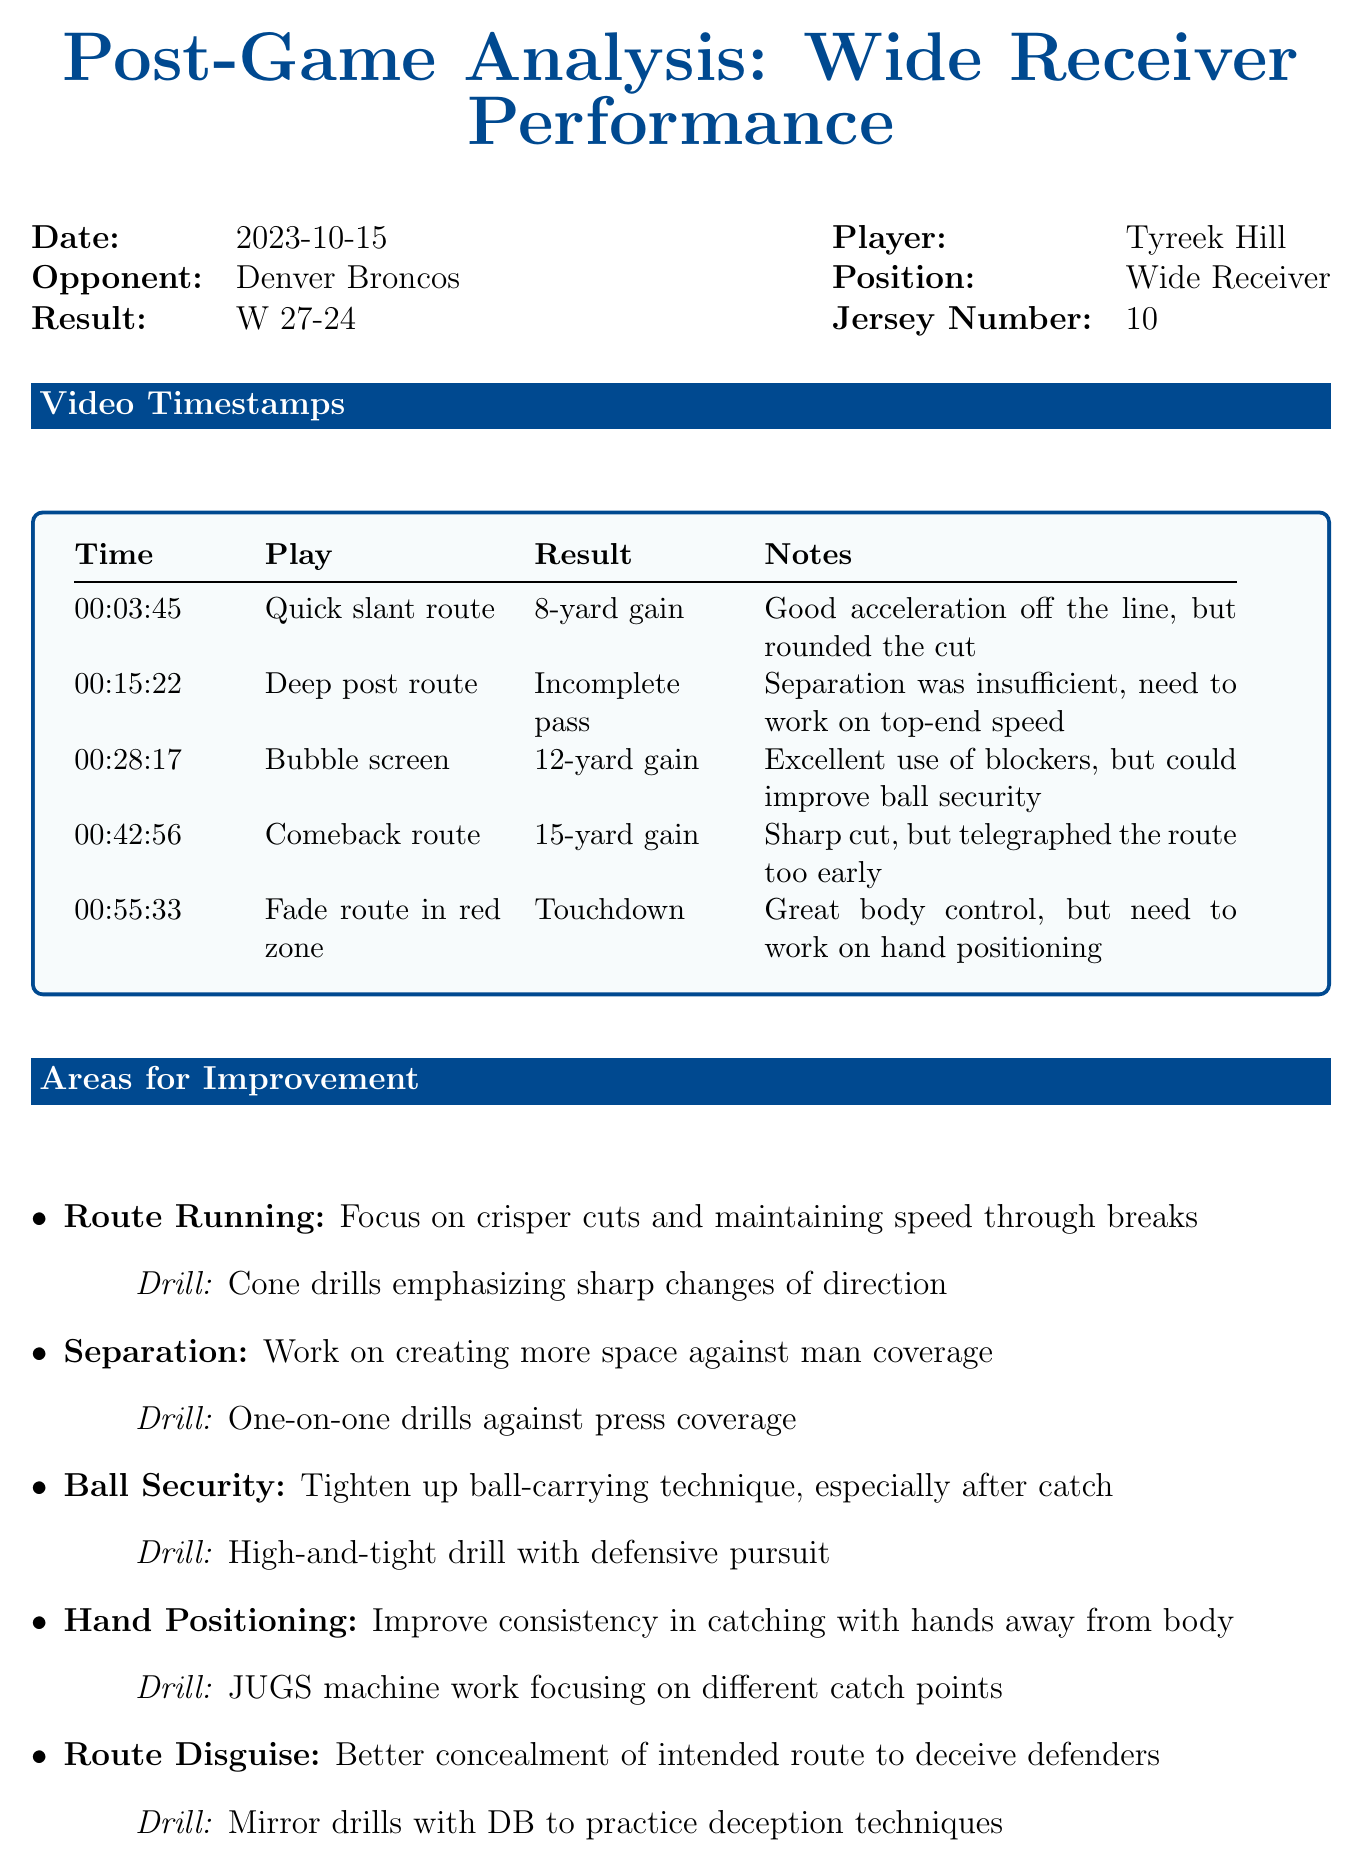What is the date of the game? The date of the game is specified in the document under game info.
Answer: 2023-10-15 Who is the player analyzed? The player information section denotes the name of the athlete being evaluated.
Answer: Tyreek Hill What was the result of the game? The result is indicated in the game info section.
Answer: W 27-24 What time did the quick slant route occur? The timestamps provide the exact time each play occurred in the game.
Answer: 00:03:45 What area for improvement focuses on ball-carrying technique? The improvement areas section lists specific skills to work on, including a focus on ball security.
Answer: Ball Security What rating did Tyreek Hill receive for his performance? The overall performance rating summarises the player’s evaluation score in the document.
Answer: 7 What is the immediate action suggested? The immediate action is detailed in the next steps section regarding video footage review.
Answer: Review video footage together What drill is suggested for improving hand positioning? The suggested drills for each area of improvement are highlighted in the document related to hand positioning.
Answer: JUGS machine work What strength was observed in Tyreek Hill's performance? The coaching notes section lists observed strengths in the player's performance.
Answer: Exceptional speed and agility 